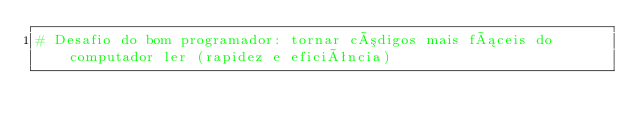Convert code to text. <code><loc_0><loc_0><loc_500><loc_500><_Python_># Desafio do bom programador: tornar códigos mais fáceis do computador ler (rapidez e eficiência)
</code> 